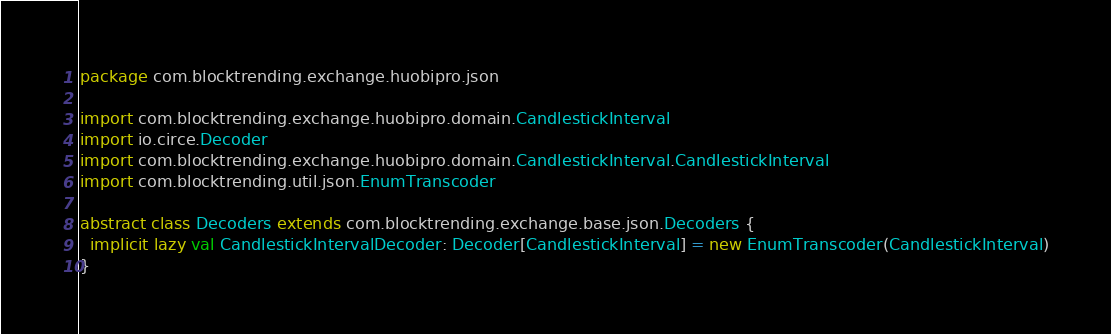<code> <loc_0><loc_0><loc_500><loc_500><_Scala_>package com.blocktrending.exchange.huobipro.json

import com.blocktrending.exchange.huobipro.domain.CandlestickInterval
import io.circe.Decoder
import com.blocktrending.exchange.huobipro.domain.CandlestickInterval.CandlestickInterval
import com.blocktrending.util.json.EnumTranscoder

abstract class Decoders extends com.blocktrending.exchange.base.json.Decoders {
  implicit lazy val CandlestickIntervalDecoder: Decoder[CandlestickInterval] = new EnumTranscoder(CandlestickInterval)
}

</code> 